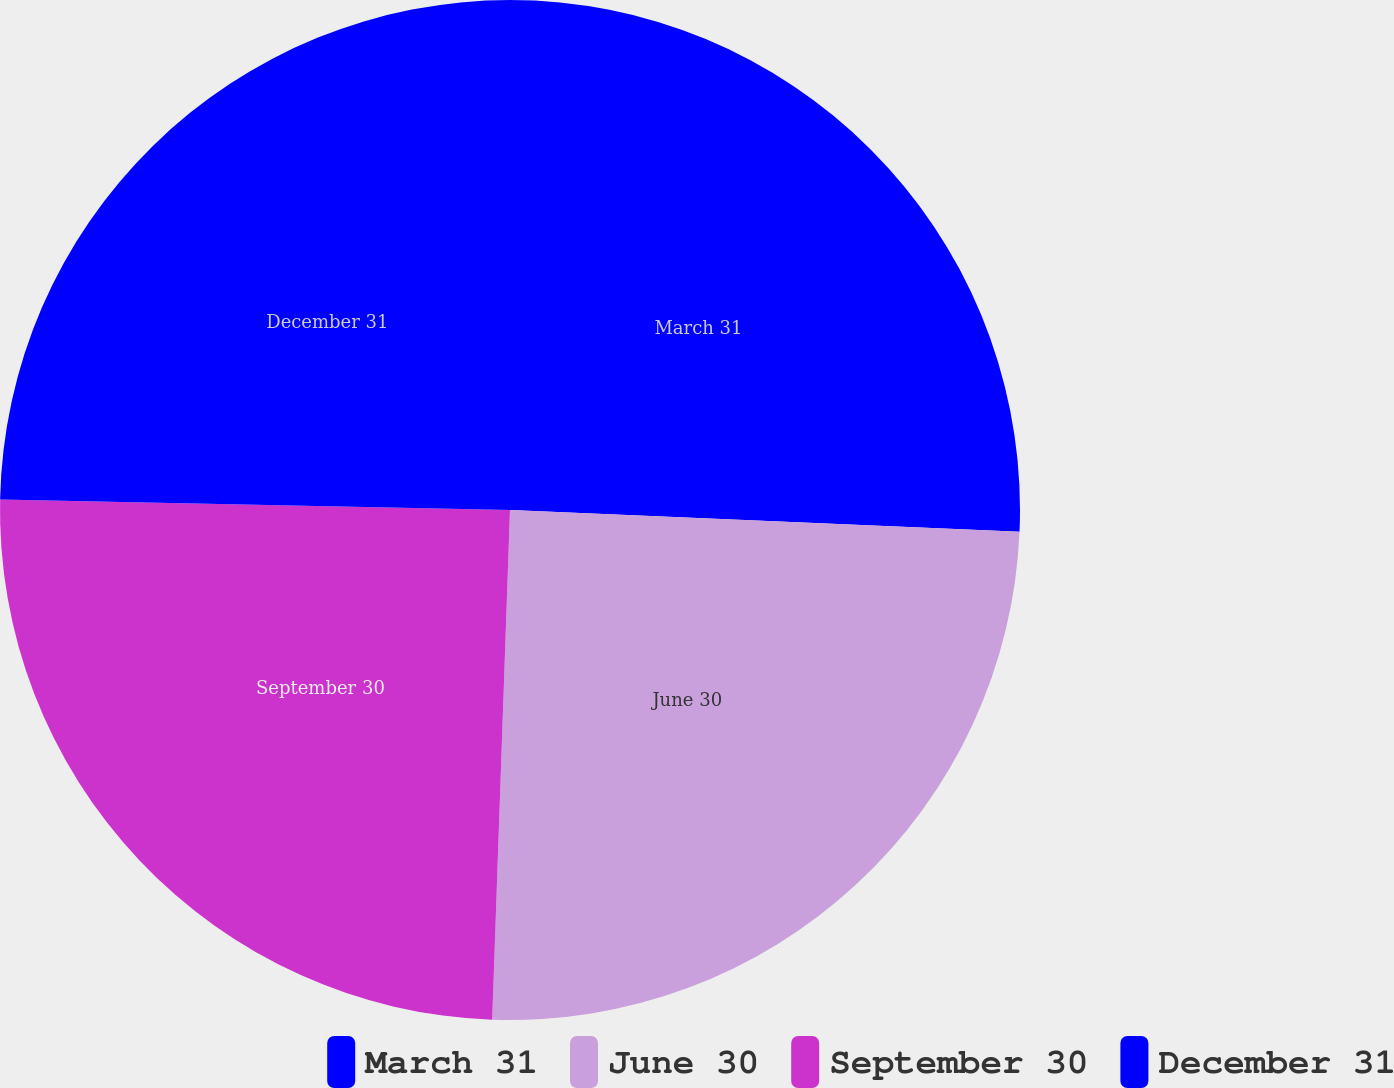<chart> <loc_0><loc_0><loc_500><loc_500><pie_chart><fcel>March 31<fcel>June 30<fcel>September 30<fcel>December 31<nl><fcel>25.68%<fcel>24.87%<fcel>24.77%<fcel>24.67%<nl></chart> 